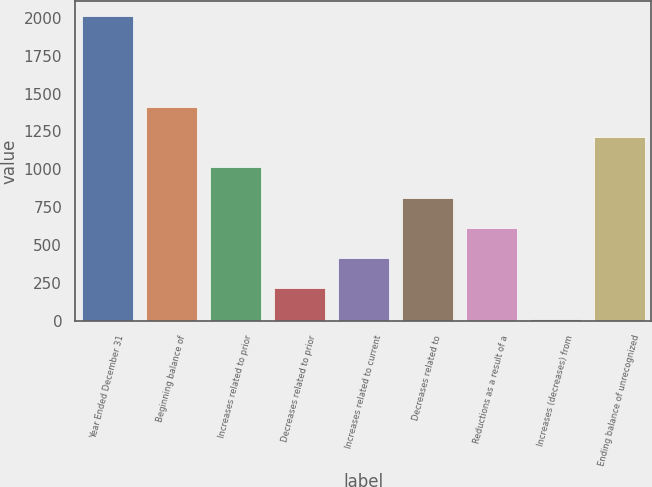<chart> <loc_0><loc_0><loc_500><loc_500><bar_chart><fcel>Year Ended December 31<fcel>Beginning balance of<fcel>Increases related to prior<fcel>Decreases related to prior<fcel>Increases related to current<fcel>Decreases related to<fcel>Reductions as a result of a<fcel>Increases (decreases) from<fcel>Ending balance of unrecognized<nl><fcel>2012<fcel>1412.6<fcel>1013<fcel>213.8<fcel>413.6<fcel>813.2<fcel>613.4<fcel>14<fcel>1212.8<nl></chart> 